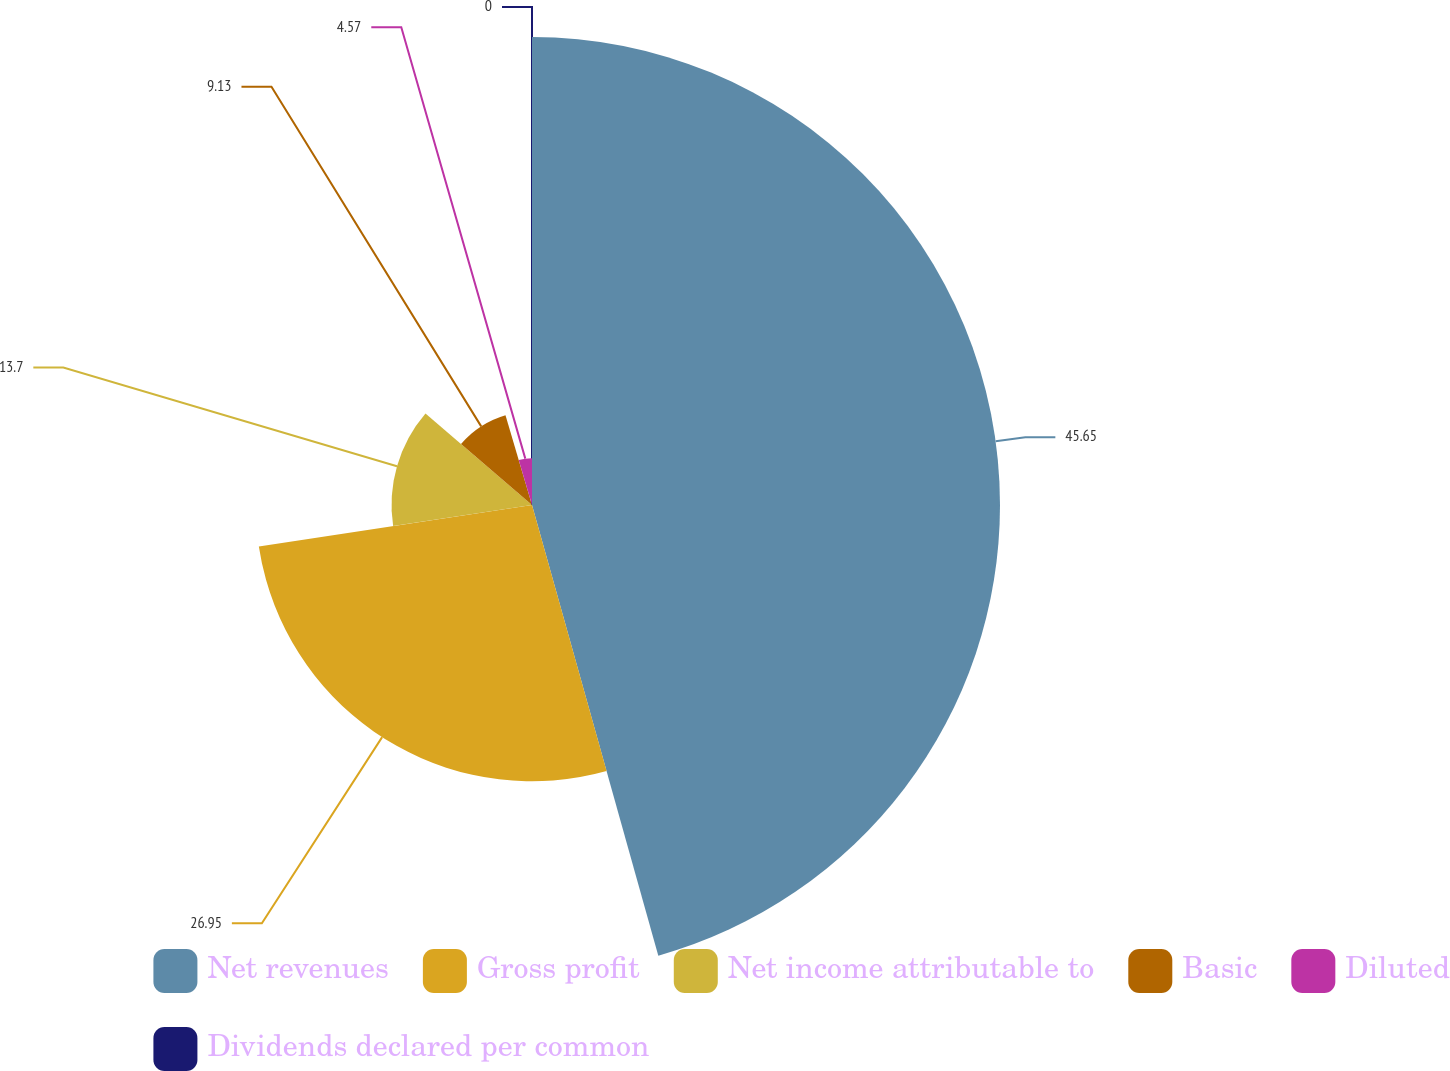<chart> <loc_0><loc_0><loc_500><loc_500><pie_chart><fcel>Net revenues<fcel>Gross profit<fcel>Net income attributable to<fcel>Basic<fcel>Diluted<fcel>Dividends declared per common<nl><fcel>45.65%<fcel>26.95%<fcel>13.7%<fcel>9.13%<fcel>4.57%<fcel>0.0%<nl></chart> 